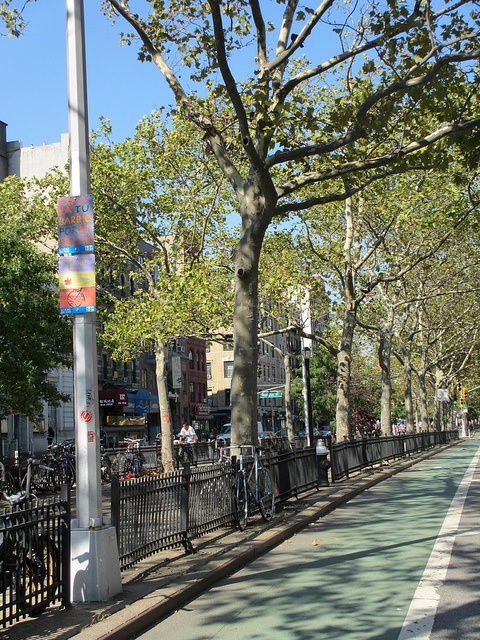Describe the objects in this image and their specific colors. I can see bicycle in darkgray, black, gray, maroon, and khaki tones, bicycle in darkgray, black, gray, and blue tones, bicycle in darkgray, black, gray, and navy tones, fire hydrant in darkgray, black, gray, and lightgray tones, and bicycle in darkgray, gray, and black tones in this image. 